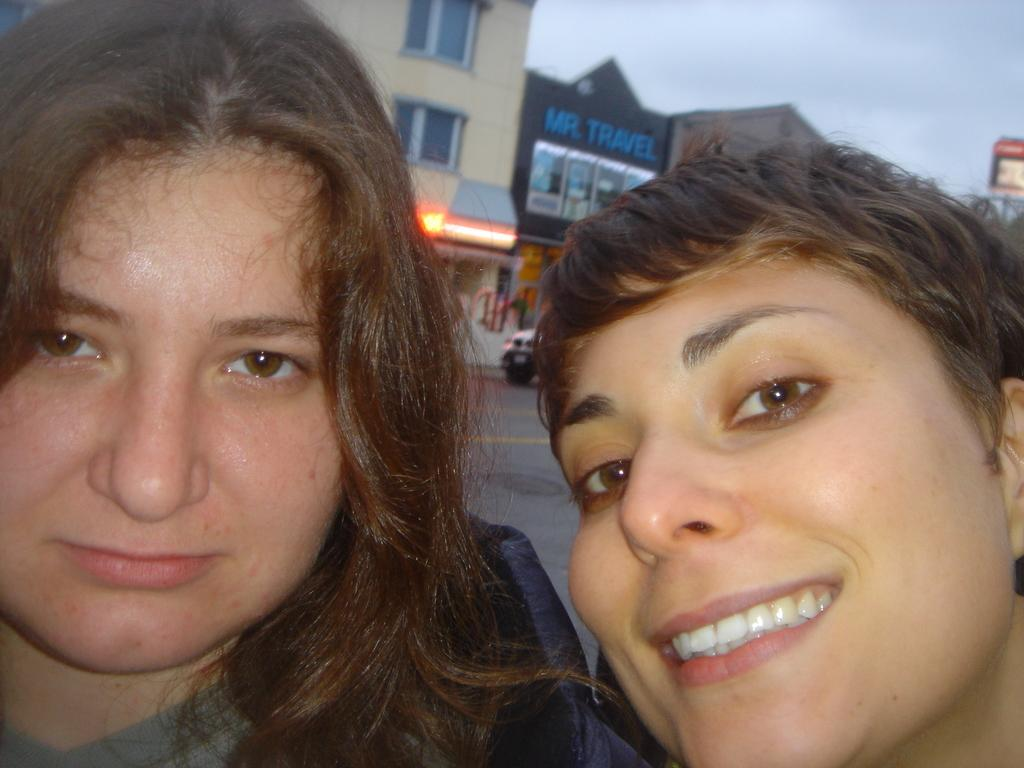How many women are present in the image? There are two women in the image. Can you describe the facial expression of one of the women? One of the women is smiling. What can be seen in the background of the image? There is a road, a vehicle, hoardings, buildings, and clouds in the sky visible in the background. What type of bell can be heard ringing in the image? There is no bell present or ringing in the image. Is there any snow visible in the image? No, there is no snow visible in the image; it is not mentioned in the provided facts. 